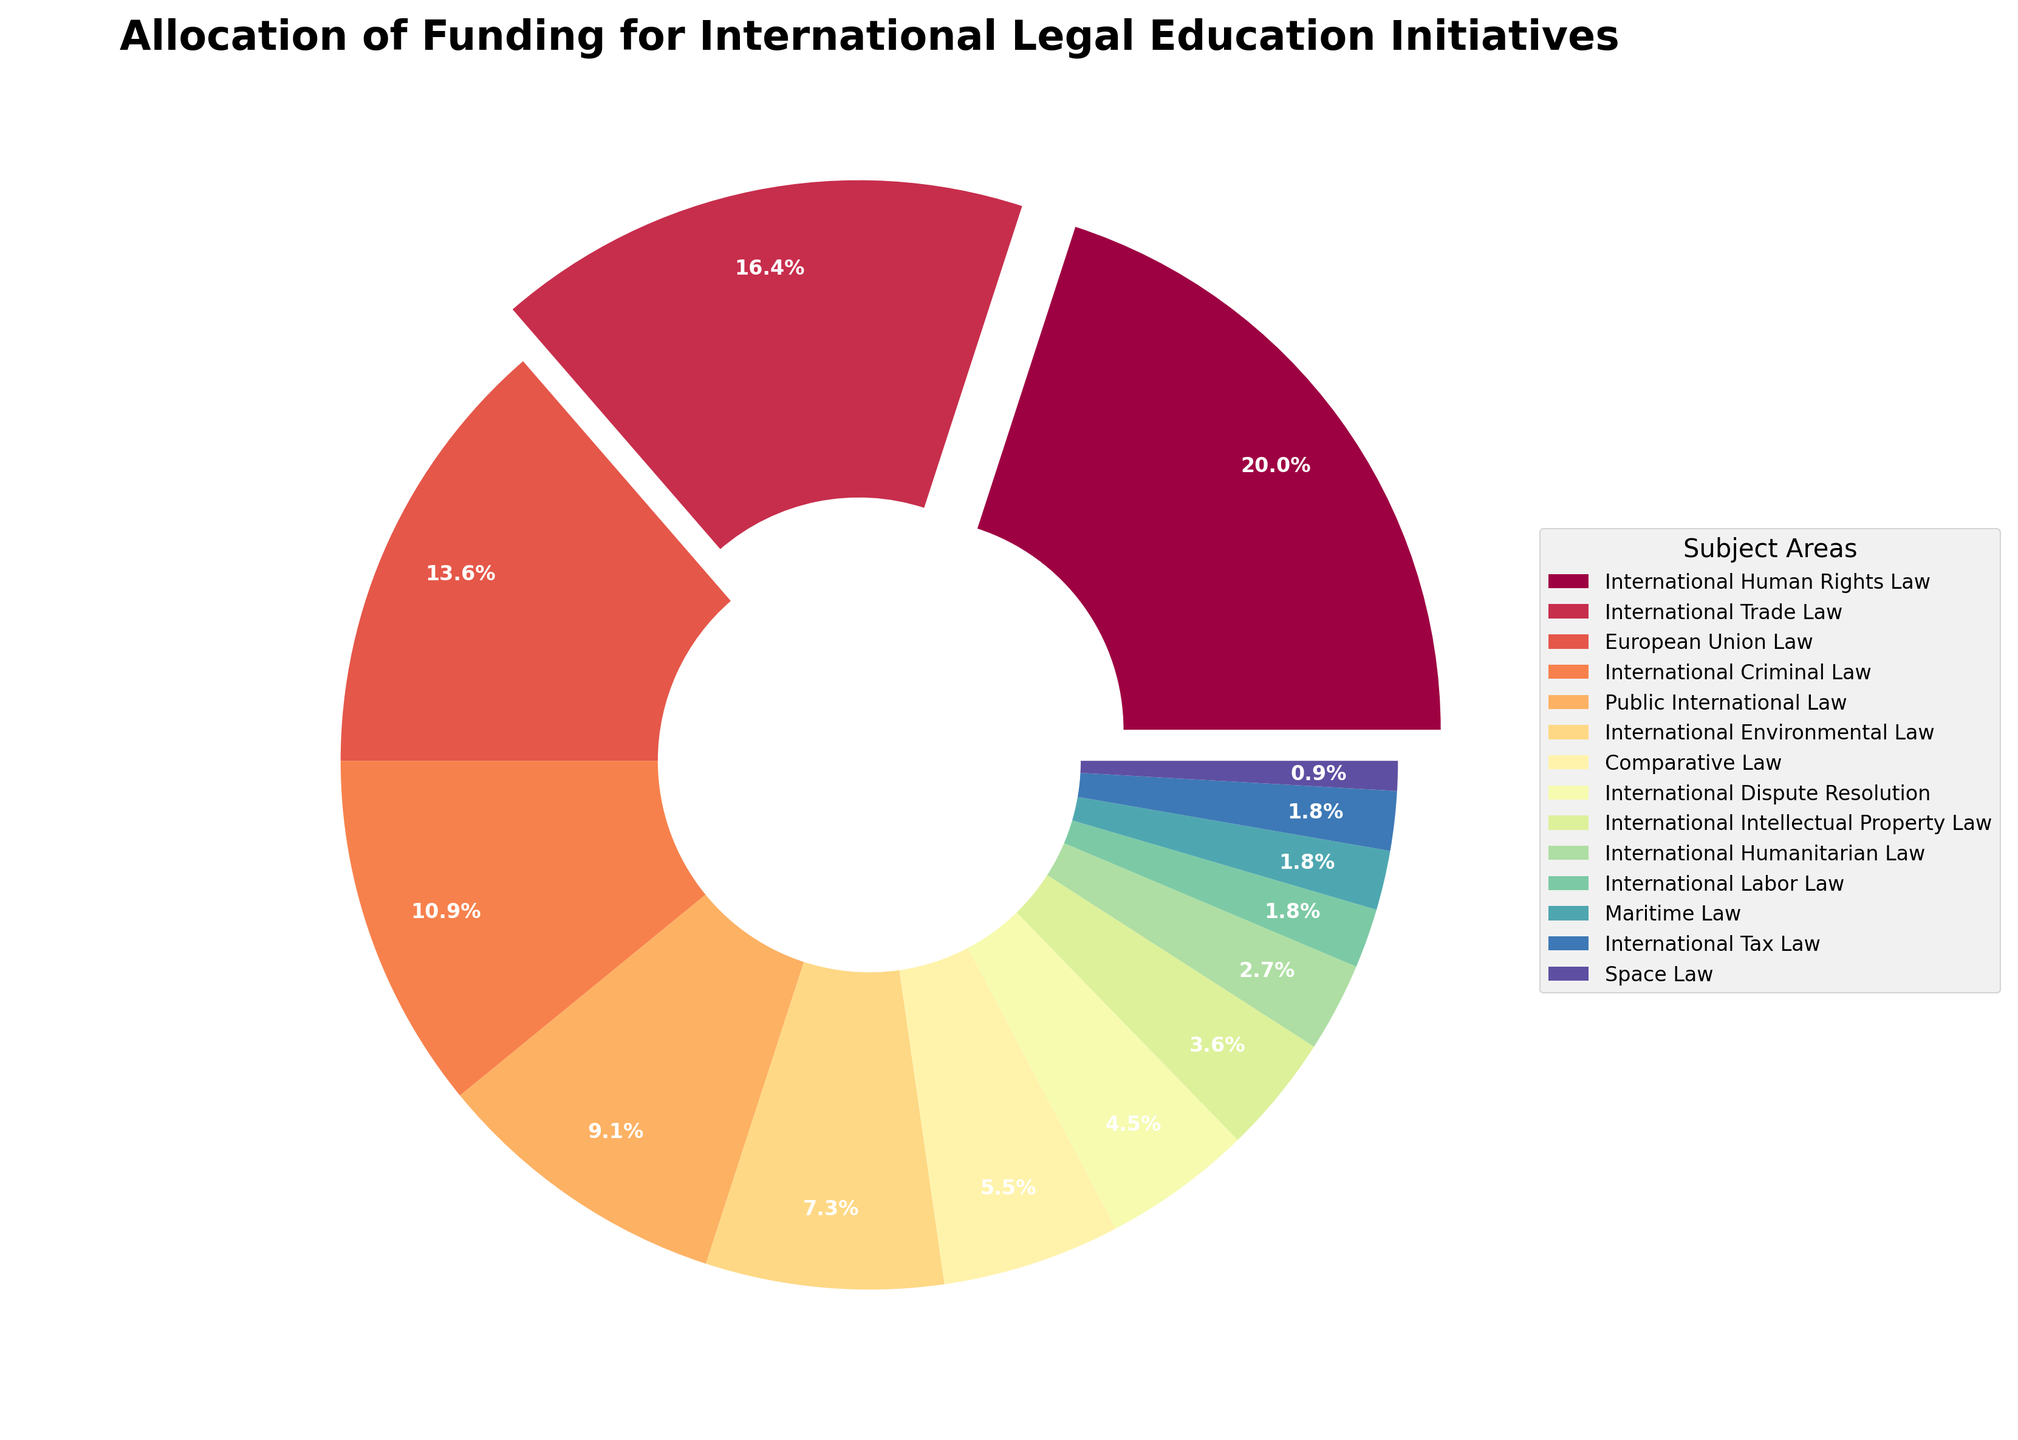Which subject area receives the highest percentage of funding? Look at the largest wedge in the pie chart; it's labeled "International Human Rights Law" with a funding percentage of 22%.
Answer: International Human Rights Law Which subject areas receive more than 20% of the funding? Identify the wedges with percentages greater than 20%. Only "International Human Rights Law" has 22%, which is above 20%.
Answer: International Human Rights Law What is the difference in funding percentage between International Trade Law and International Criminal Law? Locate the wedges for both subject areas: International Trade Law (18%) and International Criminal Law (12%). Subtract the smaller percentage from the larger one: 18% - 12% = 6%.
Answer: 6% Which subject area receives the least amount of funding and what is that percentage? Identify the smallest wedge in the pie chart; it's labeled "Space Law" with a funding percentage of 1%.
Answer: Space Law, 1% How much more funding does International Human Rights Law receive compared to European Union Law? Identify the wedges for both subject areas: International Human Rights Law (22%) and European Union Law (15%). Subtract the smaller percentage from the larger one: 22% - 15% = 7%.
Answer: 7% Which colors represent the wedges for International Trade Law and Space Law? Look at the colors of the wedges labeled "International Trade Law" and "Space Law". Identify that International Trade Law has a certain color (describe as needed) and Space Law has a different color (describe accordingly).
Answer: [Color description needed, cannot infer from data] What is the combined funding percentage for International Tax Law and Maritime Law? Identify the wedges for both subject areas: International Tax Law (2%) and Maritime Law (2%). Add their percentages: 2% + 2% = 4%.
Answer: 4% Among International Environmental Law, Comparative Law, and International Dispute Resolution, which subject area receives the highest funding percentage? Compare the percentages of these subject areas: International Environmental Law (8%), Comparative Law (6%), and International Dispute Resolution (5%). The highest is 8%.
Answer: International Environmental Law What is the total percentage of funding allocated to subject areas receiving less than 5% each? Identify subject areas with less than 5%: International Intellectual Property Law (4%), International Humanitarian Law (3%), International Labor Law (2%), Maritime Law (2%), International Tax Law (2%), and Space Law (1%). Sum their percentages: 4% + 3% + 2% + 2% + 2% + 1% = 14%.
Answer: 14% 